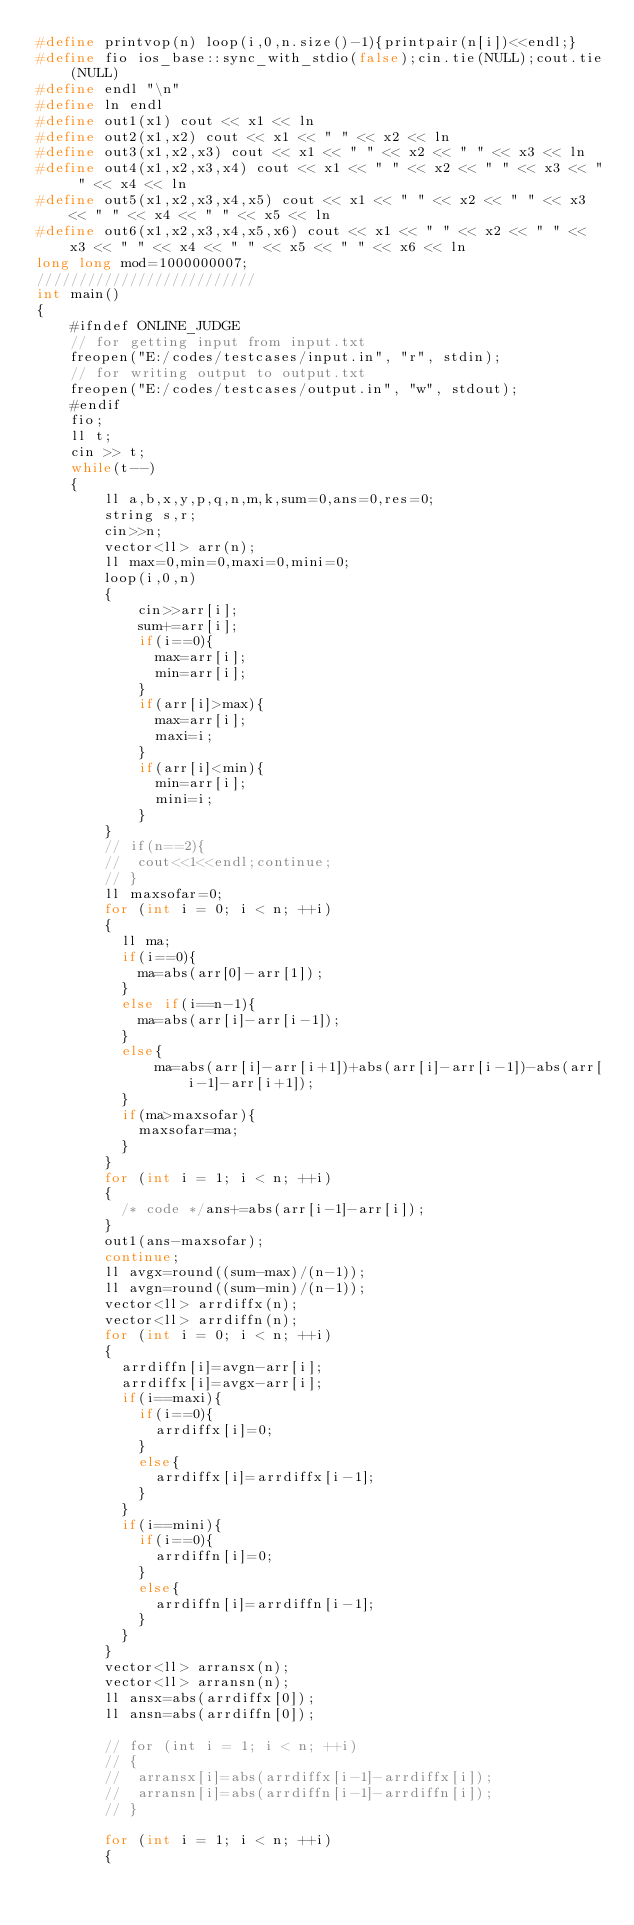<code> <loc_0><loc_0><loc_500><loc_500><_C++_>#define printvop(n) loop(i,0,n.size()-1){printpair(n[i])<<endl;}
#define fio ios_base::sync_with_stdio(false);cin.tie(NULL);cout.tie(NULL)
#define endl "\n"
#define ln endl
#define out1(x1) cout << x1 << ln
#define out2(x1,x2) cout << x1 << " " << x2 << ln
#define out3(x1,x2,x3) cout << x1 << " " << x2 << " " << x3 << ln
#define out4(x1,x2,x3,x4) cout << x1 << " " << x2 << " " << x3 << " " << x4 << ln
#define out5(x1,x2,x3,x4,x5) cout << x1 << " " << x2 << " " << x3 << " " << x4 << " " << x5 << ln
#define out6(x1,x2,x3,x4,x5,x6) cout << x1 << " " << x2 << " " << x3 << " " << x4 << " " << x5 << " " << x6 << ln
long long mod=1000000007;
//////////////////////////
int main()
{
    #ifndef ONLINE_JUDGE
    // for getting input from input.txt
    freopen("E:/codes/testcases/input.in", "r", stdin);
    // for writing output to output.txt
    freopen("E:/codes/testcases/output.in", "w", stdout);
    #endif
    fio;
    ll t;
    cin >> t;
    while(t--)
    {
        ll a,b,x,y,p,q,n,m,k,sum=0,ans=0,res=0;
        string s,r;
        cin>>n;
        vector<ll> arr(n);
        ll max=0,min=0,maxi=0,mini=0;
        loop(i,0,n)
        {
            cin>>arr[i];
            sum+=arr[i];
            if(i==0){
            	max=arr[i];
            	min=arr[i];
            }
            if(arr[i]>max){
            	max=arr[i];
            	maxi=i;
            }
            if(arr[i]<min){
            	min=arr[i];
            	mini=i;
            }
        }
        // if(n==2){
        // 	cout<<1<<endl;continue;
        // }
        ll maxsofar=0;
        for (int i = 0; i < n; ++i)
        {	
        	ll ma;
        	if(i==0){
        		ma=abs(arr[0]-arr[1]);
        	}
        	else if(i==n-1){
        		ma=abs(arr[i]-arr[i-1]);
        	}
        	else{
        	    ma=abs(arr[i]-arr[i+1])+abs(arr[i]-arr[i-1])-abs(arr[i-1]-arr[i+1]);
        	}
        	if(ma>maxsofar){
	        	maxsofar=ma;
        	}
        }
        for (int i = 1; i < n; ++i)
        {
        	/* code */ans+=abs(arr[i-1]-arr[i]);
        }
        out1(ans-maxsofar);
        continue;
        ll avgx=round((sum-max)/(n-1));
        ll avgn=round((sum-min)/(n-1));
        vector<ll> arrdiffx(n);
        vector<ll> arrdiffn(n);
        for (int i = 0; i < n; ++i)
        {
        	arrdiffn[i]=avgn-arr[i];
        	arrdiffx[i]=avgx-arr[i];
        	if(i==maxi){
        		if(i==0){
        			arrdiffx[i]=0;	
        		}
        		else{
        			arrdiffx[i]=arrdiffx[i-1];
        		}
        	}
        	if(i==mini){
        		if(i==0){
        			arrdiffn[i]=0;	
        		}
        		else{
        			arrdiffn[i]=arrdiffn[i-1];
        		}
        	}
        }
        vector<ll> arransx(n);
        vector<ll> arransn(n);
        ll ansx=abs(arrdiffx[0]);
        ll ansn=abs(arrdiffn[0]);

        // for (int i = 1; i < n; ++i)
        // {
        // 	arransx[i]=abs(arrdiffx[i-1]-arrdiffx[i]);
        // 	arransn[i]=abs(arrdiffn[i-1]-arrdiffn[i]);
        // }

        for (int i = 1; i < n; ++i)
        {</code> 